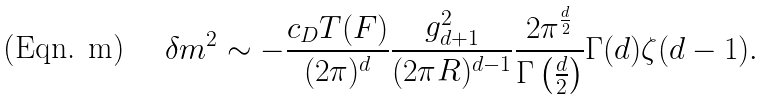Convert formula to latex. <formula><loc_0><loc_0><loc_500><loc_500>\delta m ^ { 2 } \sim - \frac { c _ { D } T ( F ) } { ( 2 \pi ) ^ { d } } \frac { g _ { d + 1 } ^ { 2 } } { ( 2 \pi R ) ^ { d - 1 } } \frac { 2 \pi ^ { \frac { d } { 2 } } } { \Gamma \left ( \frac { d } { 2 } \right ) } \Gamma ( d ) \zeta ( d - 1 ) .</formula> 